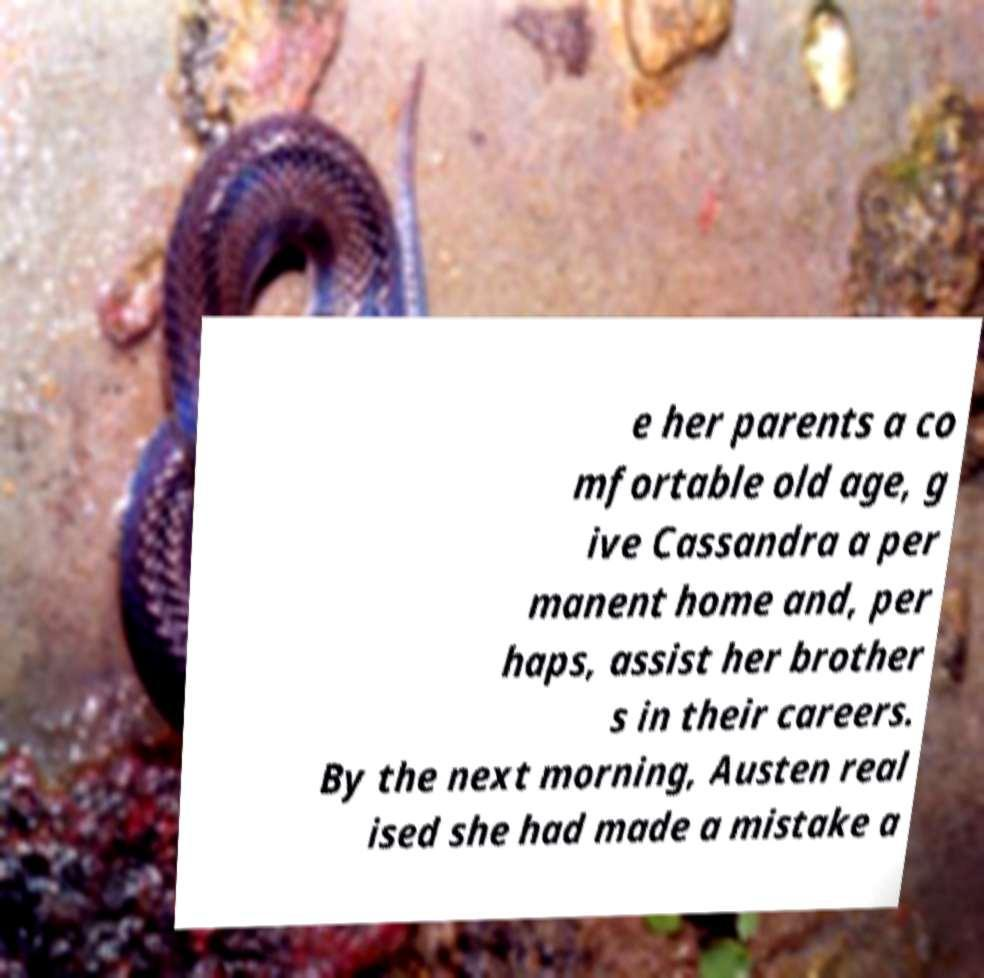Can you accurately transcribe the text from the provided image for me? e her parents a co mfortable old age, g ive Cassandra a per manent home and, per haps, assist her brother s in their careers. By the next morning, Austen real ised she had made a mistake a 